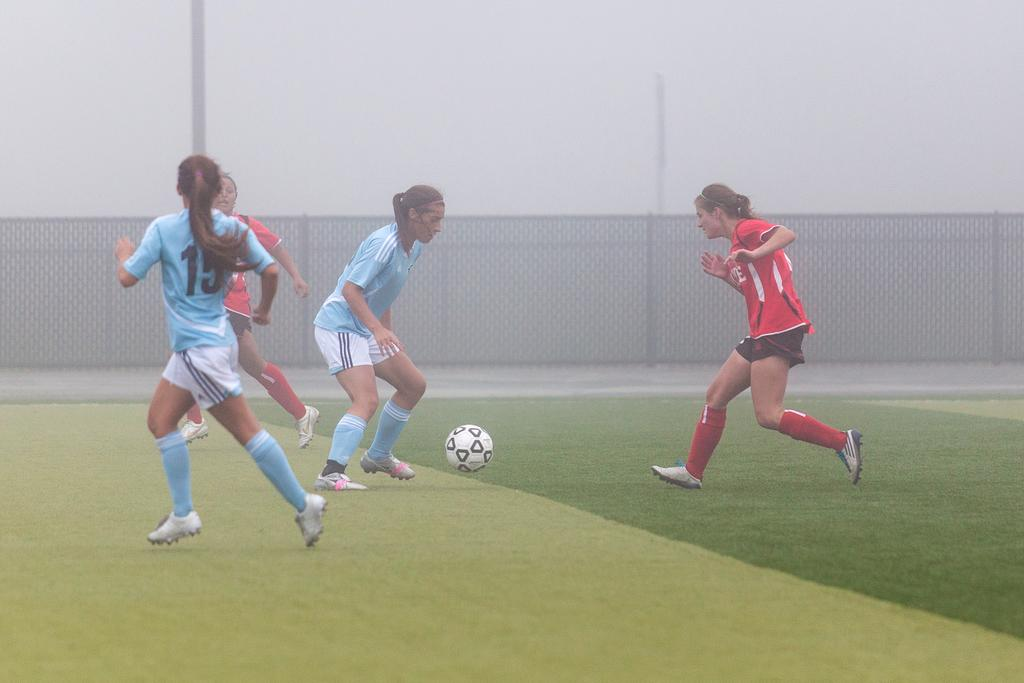<image>
Relay a brief, clear account of the picture shown. Player number 15 keeps an eye on the player with the ball as she runs. 